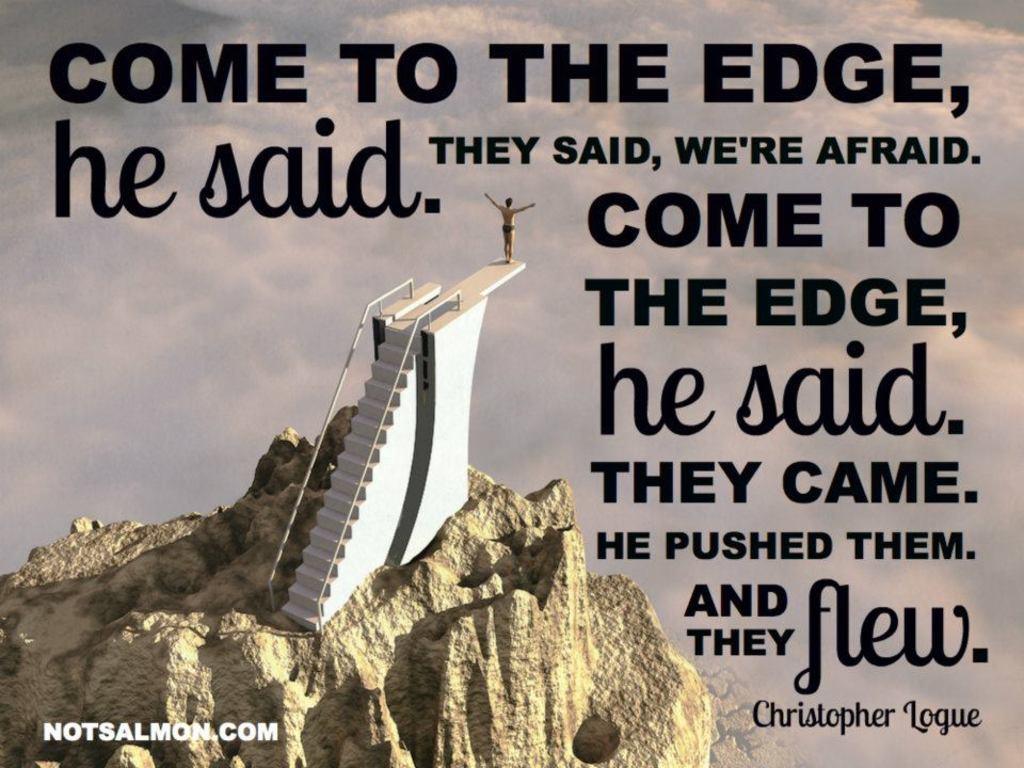<image>
Share a concise interpretation of the image provided. A view of stairs on a mountain top with notsalmon.com in white letters. 